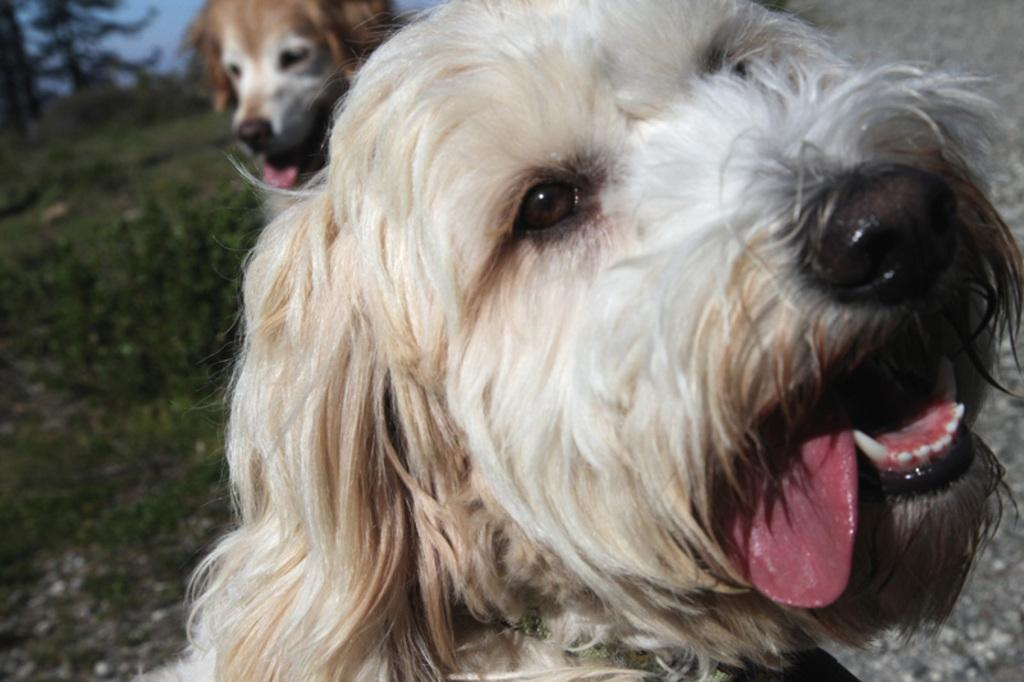What type of animals are in the picture? There are dogs in the picture. What can be seen in the top left hand side of the picture? There is a tree in the top left hand side of the picture. What is visible at the top of the picture? The sky is visible at the top of the picture. What type of produce can be seen in the image? There is no produce present in the image. 